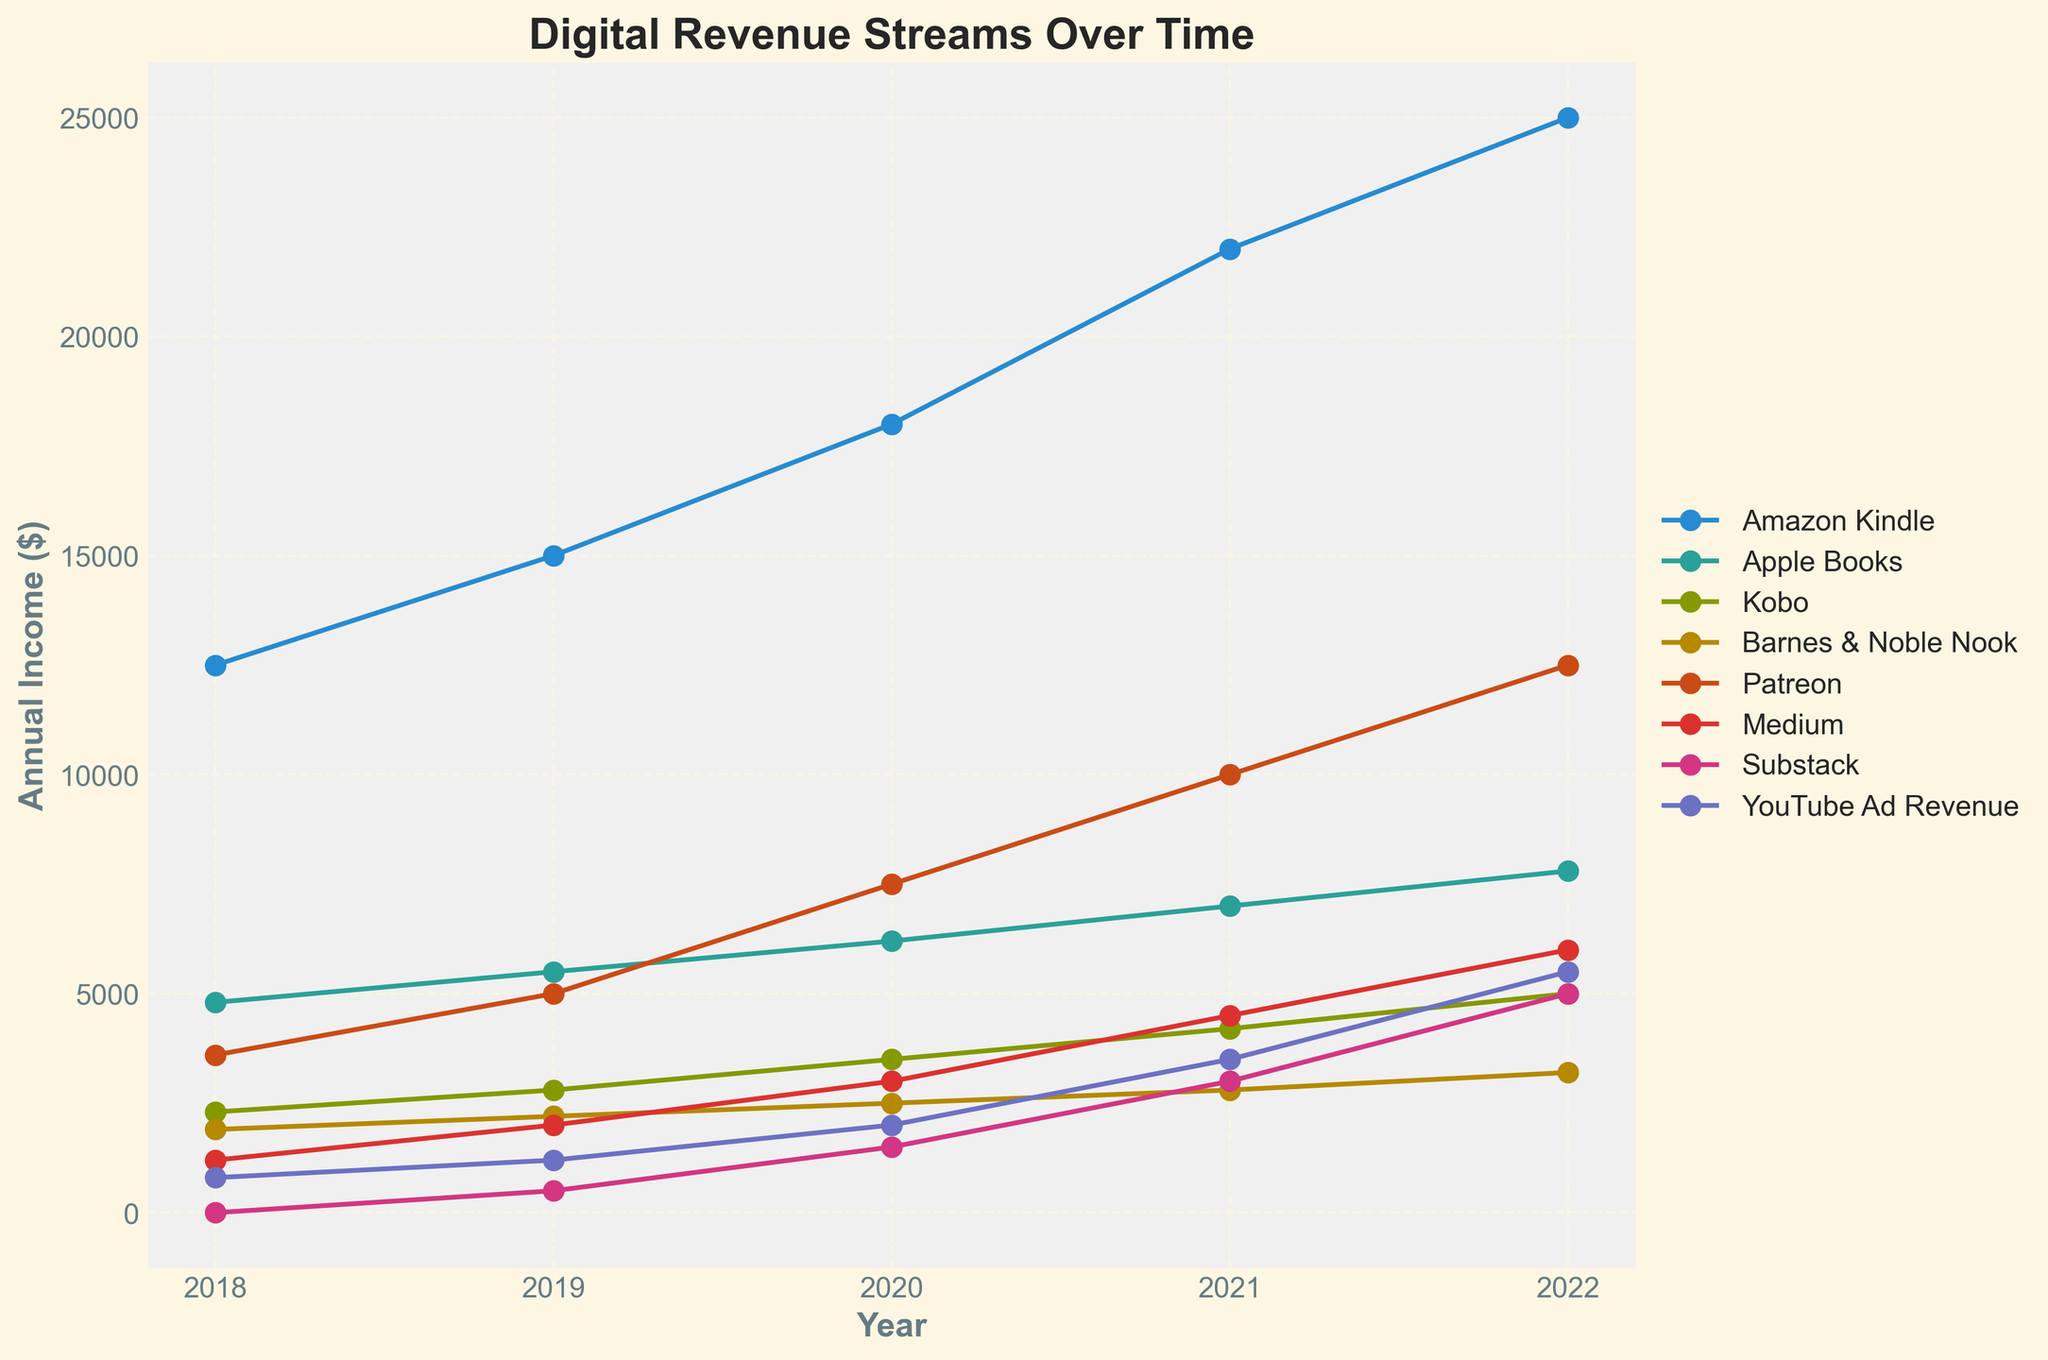What is the total income from Amazon Kindle across all years? To find the total income from Amazon Kindle over all years, sum the values for each year: 2018 (12500) + 2019 (15000) + 2020 (18000) + 2021 (22000) + 2022 (25000). The calculation is 12500 + 15000 + 18000 + 22000 + 25000 = 92500.
Answer: 92500 Which year had the highest total income from all platforms combined? To find this, calculate the sum of the income from all platforms for each year, and then identify the year with the highest sum:
- 2018: 12500 + 4800 + 2300 + 1900 + 3600 + 1200 + 0 + 800 = 27100
- 2019: 15000 + 5500 + 2800 + 2200 + 5000 + 2000 + 500 + 1200 = 34200
- 2020: 18000 + 6200 + 3500 + 2500 + 7500 + 3000 + 1500 + 2000 = 44200
- 2021: 22000 + 7000 + 4200 + 2800 + 10000 + 4500 + 3000 + 3500 = 57000
- 2022: 25000 + 7800 + 5000 + 3200 + 12500 + 6000 + 5000 + 5500 = 70000
The highest sum is for 2022.
Answer: 2022 What was the average annual income from Patreon between 2018 and 2022? To calculate the average annual income from Patreon, sum the income for each year and divide by the number of years. The sum is 3600 (2018) + 5000 (2019) + 7500 (2020) + 10000 (2021) + 12500 (2022). The calculation is 3600 + 5000 + 7500 + 10000 + 12500 = 38600. The average is 38600 / 5 = 7720.
Answer: 7720 Which platform showed the most significant income increase from 2018 to 2022? To find the platform with the most significant income increase, subtract the 2018 income from the 2022 income for each platform:
- Amazon Kindle: 25000 - 12500 = 12500
- Apple Books: 7800 - 4800 = 3000
- Kobo: 5000 - 2300 = 2700
- Barnes & Noble Nook: 3200 - 1900 = 1300
- Patreon: 12500 - 3600 = 8900
- Medium: 6000 - 1200 = 4800
- Substack: 5000 - 0 = 5000
- YouTube Ad Revenue: 5500 - 800 = 4700
Amazon Kindle shows the largest increase.
Answer: Amazon Kindle Did Substack have consistent earnings in all years? Observing the data for Substack, we see the revenue was 0 in 2018, 500 in 2019, 1500 in 2020, 3000 in 2021, and 5000 in 2022. It doesn’t show consistency as it varies every year.
Answer: No How did the annual income from YouTube Ad Revenue change between 2019 and 2020? The income from YouTube Ad Revenue in 2019 was 1200, while in 2020 it was 2000. The change is 2000 - 1200 = 800 increase.
Answer: Increased by 800 Compare the total revenue from Medium and Substack in 2022. Which was higher? The revenue from Medium in 2022 was 6000, and from Substack was 5000. By comparing 6000 (Medium) and 5000 (Substack), Medium had higher revenue.
Answer: Medium What was the smallest annual income for any platform in any year? To find the smallest annual income, look for the smallest value in the dataset, which is 0 for Substack in 2018.
Answer: 0 